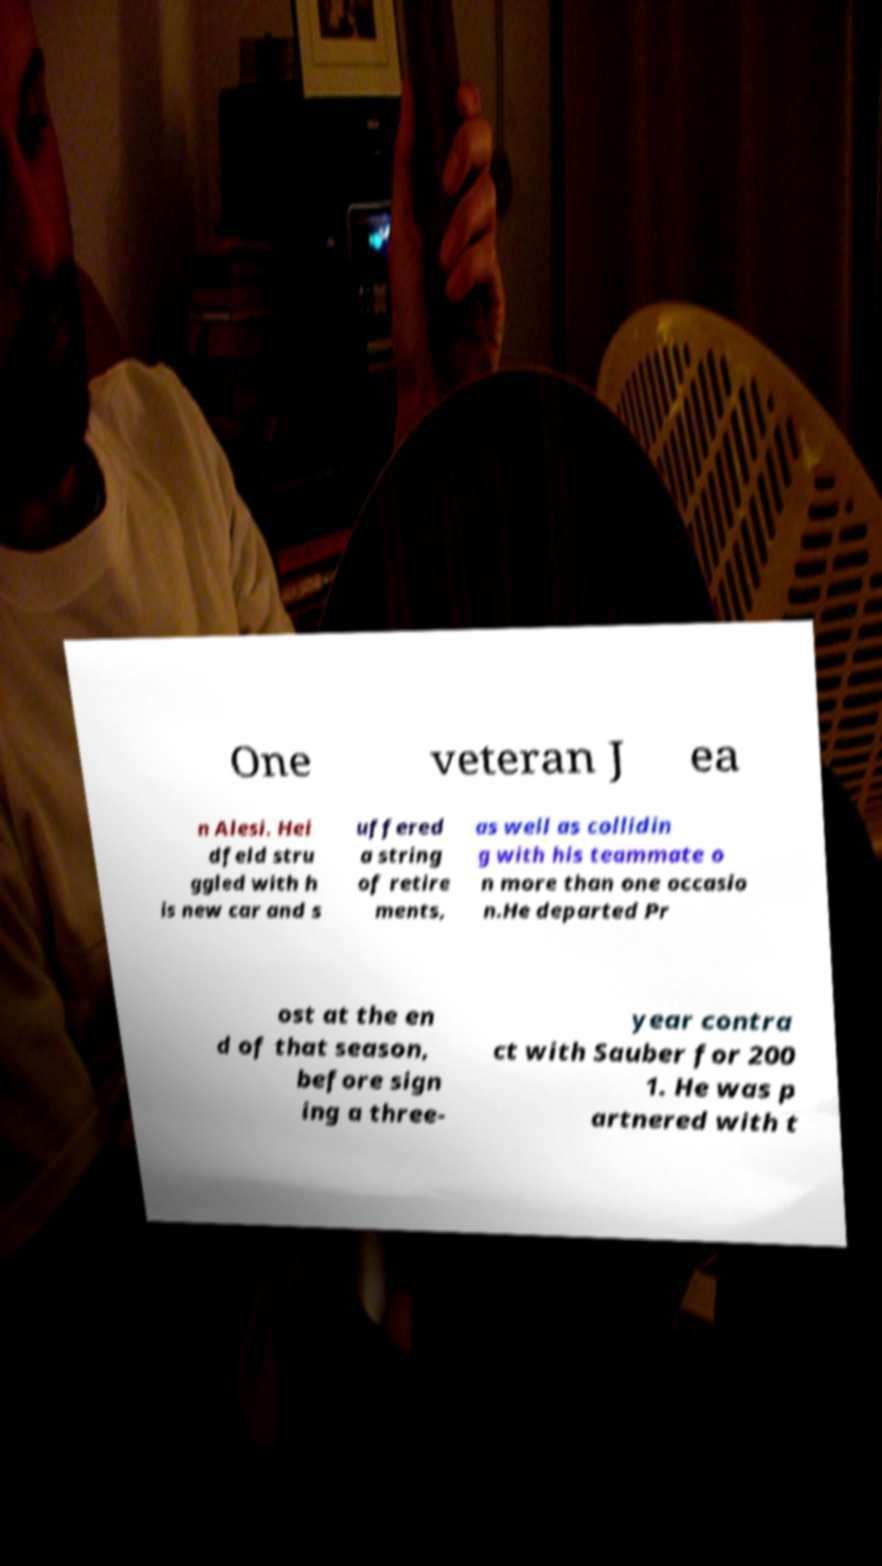What messages or text are displayed in this image? I need them in a readable, typed format. One veteran J ea n Alesi. Hei dfeld stru ggled with h is new car and s uffered a string of retire ments, as well as collidin g with his teammate o n more than one occasio n.He departed Pr ost at the en d of that season, before sign ing a three- year contra ct with Sauber for 200 1. He was p artnered with t 